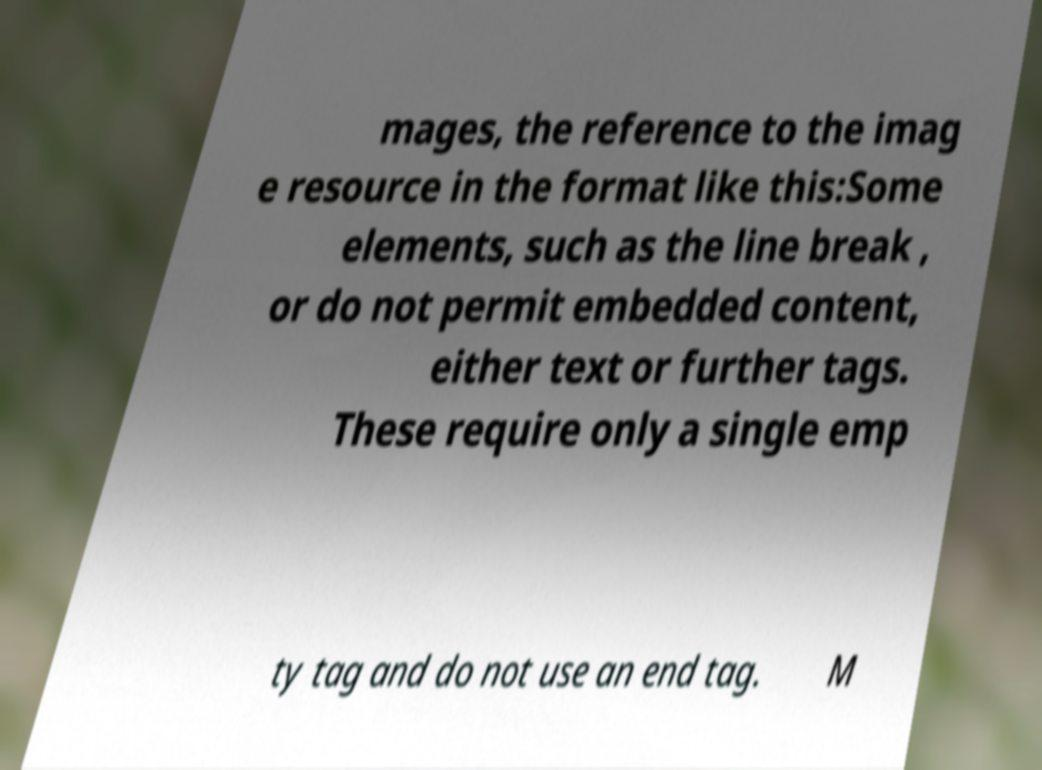Can you accurately transcribe the text from the provided image for me? mages, the reference to the imag e resource in the format like this:Some elements, such as the line break , or do not permit embedded content, either text or further tags. These require only a single emp ty tag and do not use an end tag. M 